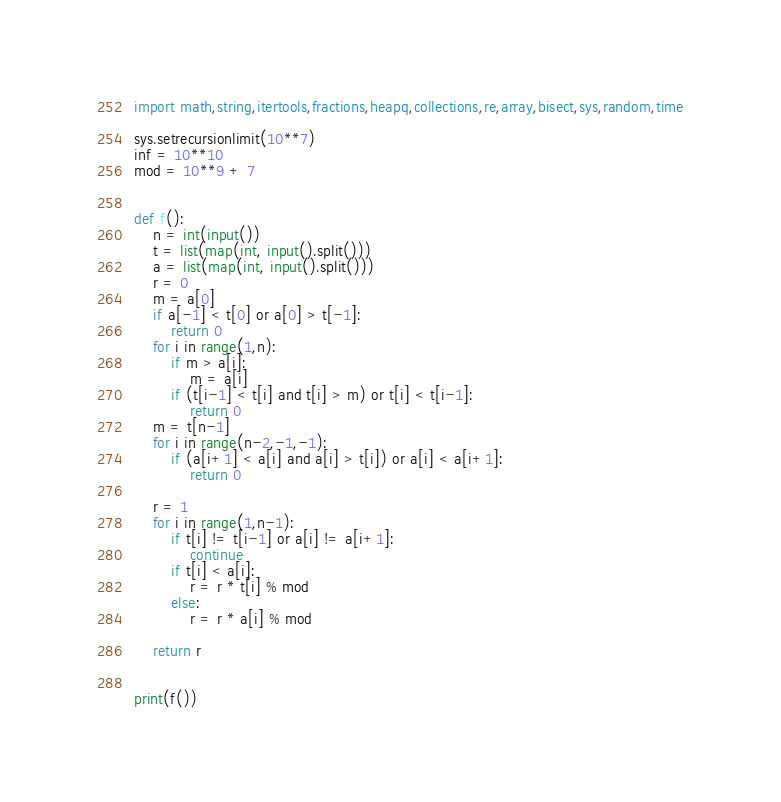Convert code to text. <code><loc_0><loc_0><loc_500><loc_500><_Python_>import math,string,itertools,fractions,heapq,collections,re,array,bisect,sys,random,time

sys.setrecursionlimit(10**7)
inf = 10**10
mod = 10**9 + 7


def f():
    n = int(input())
    t = list(map(int, input().split()))
    a = list(map(int, input().split()))
    r = 0
    m = a[0]
    if a[-1] < t[0] or a[0] > t[-1]:
        return 0
    for i in range(1,n):
        if m > a[i]:
            m = a[i]
        if (t[i-1] < t[i] and t[i] > m) or t[i] < t[i-1]:
            return 0
    m = t[n-1]
    for i in range(n-2,-1,-1):
        if (a[i+1] < a[i] and a[i] > t[i]) or a[i] < a[i+1]:
            return 0

    r = 1
    for i in range(1,n-1):
        if t[i] != t[i-1] or a[i] != a[i+1]:
            continue
        if t[i] < a[i]:
            r = r * t[i] % mod
        else:
            r = r * a[i] % mod

    return r


print(f())
</code> 